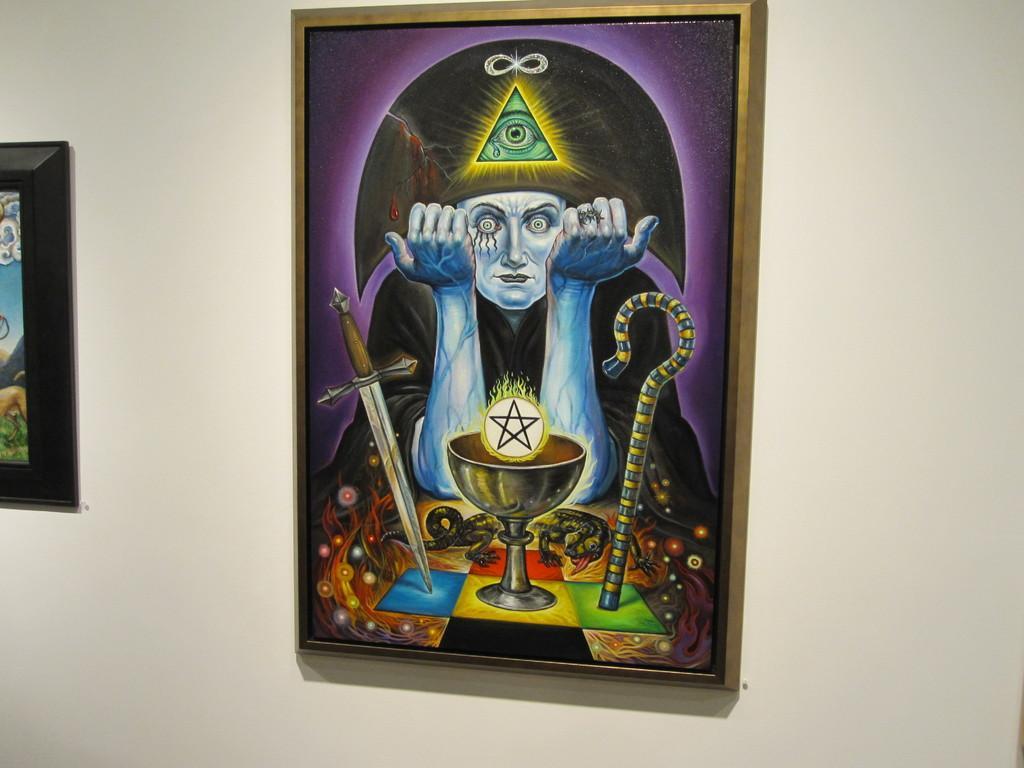How would you summarize this image in a sentence or two? In this image I can see there is a painting of a ghost on this wall. 